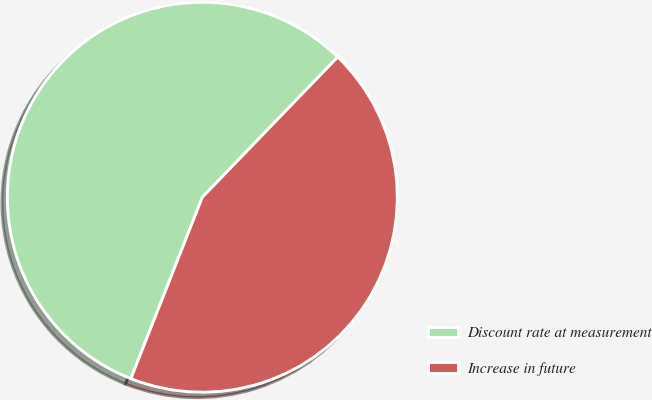Convert chart. <chart><loc_0><loc_0><loc_500><loc_500><pie_chart><fcel>Discount rate at measurement<fcel>Increase in future<nl><fcel>56.25%<fcel>43.75%<nl></chart> 